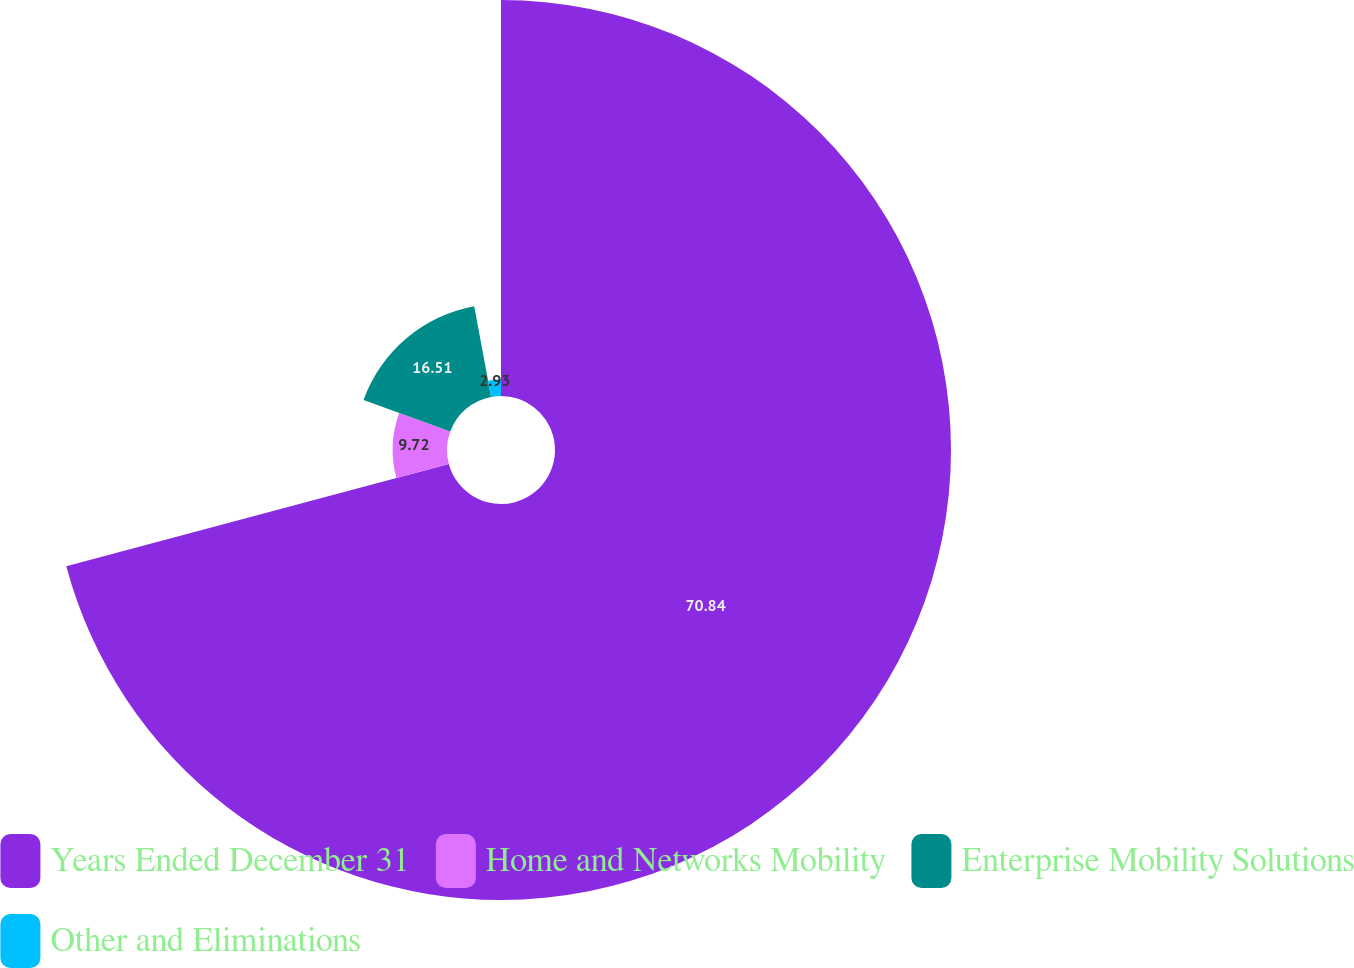<chart> <loc_0><loc_0><loc_500><loc_500><pie_chart><fcel>Years Ended December 31<fcel>Home and Networks Mobility<fcel>Enterprise Mobility Solutions<fcel>Other and Eliminations<nl><fcel>70.84%<fcel>9.72%<fcel>16.51%<fcel>2.93%<nl></chart> 